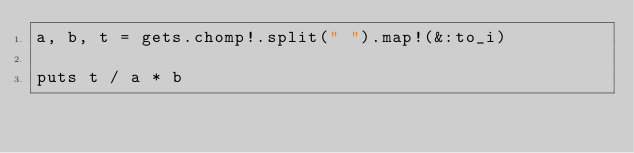Convert code to text. <code><loc_0><loc_0><loc_500><loc_500><_Ruby_>a, b, t = gets.chomp!.split(" ").map!(&:to_i)

puts t / a * b</code> 